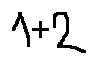<formula> <loc_0><loc_0><loc_500><loc_500>1 + 2</formula> 